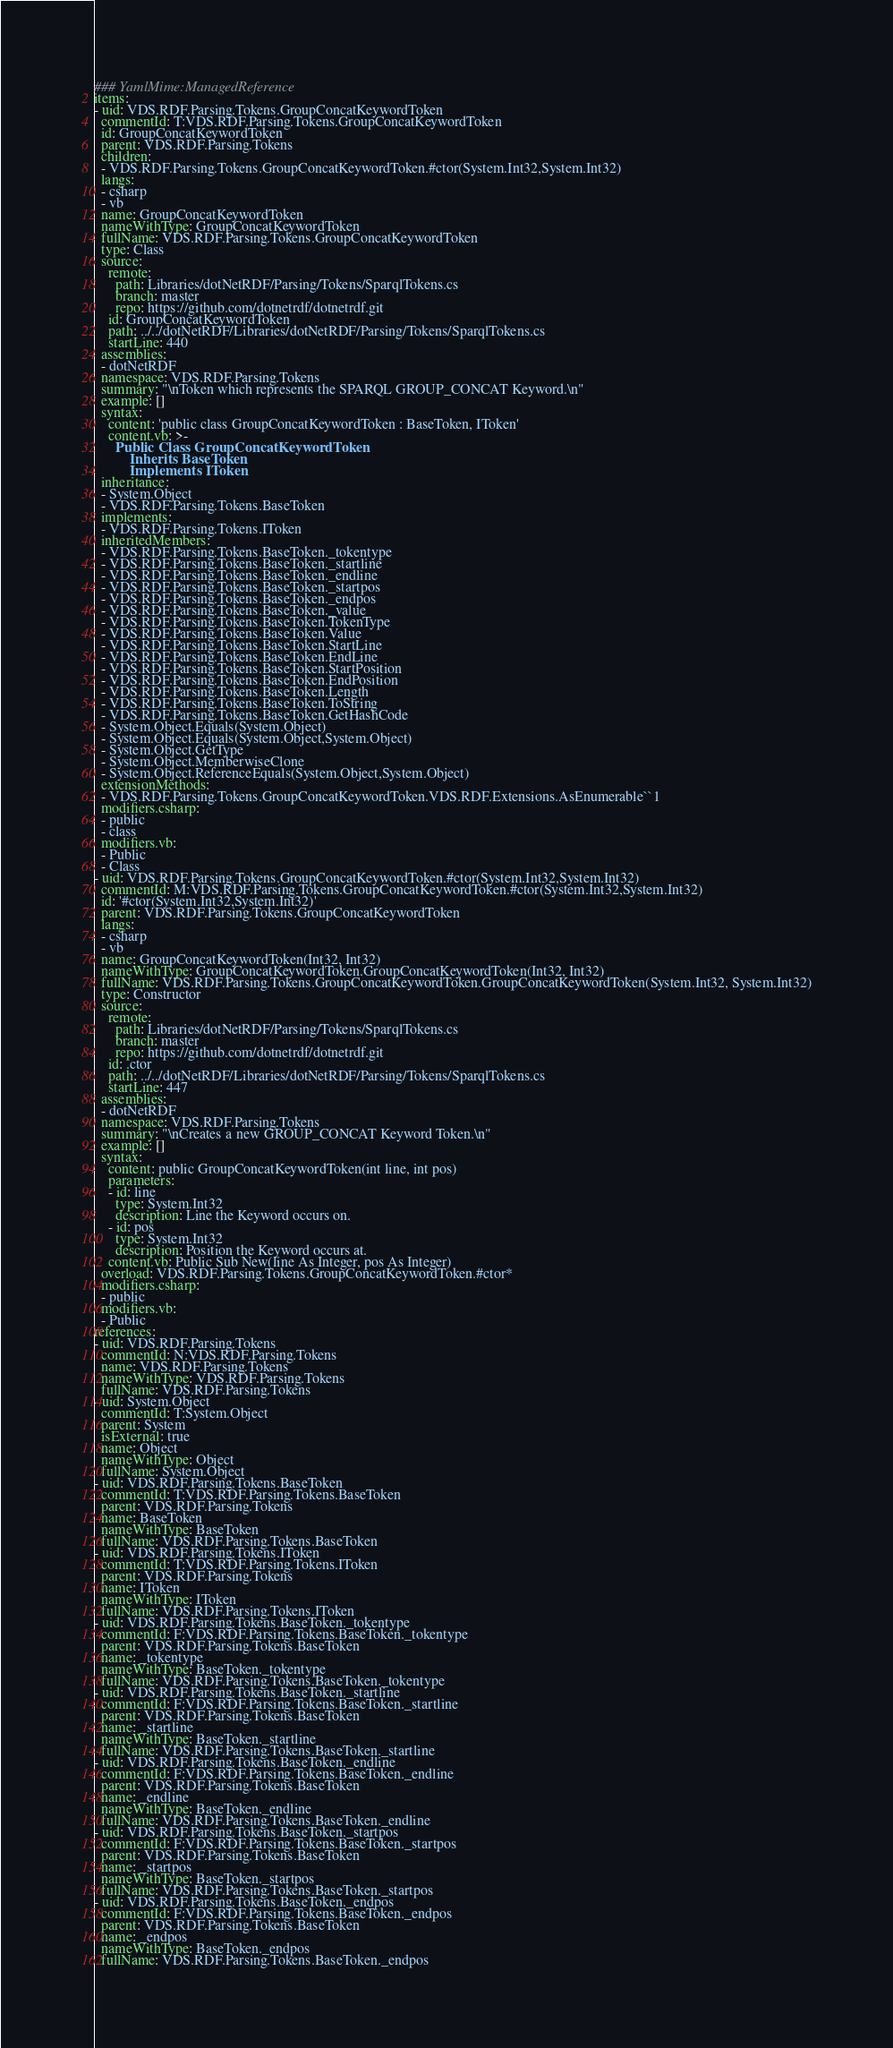Convert code to text. <code><loc_0><loc_0><loc_500><loc_500><_YAML_>### YamlMime:ManagedReference
items:
- uid: VDS.RDF.Parsing.Tokens.GroupConcatKeywordToken
  commentId: T:VDS.RDF.Parsing.Tokens.GroupConcatKeywordToken
  id: GroupConcatKeywordToken
  parent: VDS.RDF.Parsing.Tokens
  children:
  - VDS.RDF.Parsing.Tokens.GroupConcatKeywordToken.#ctor(System.Int32,System.Int32)
  langs:
  - csharp
  - vb
  name: GroupConcatKeywordToken
  nameWithType: GroupConcatKeywordToken
  fullName: VDS.RDF.Parsing.Tokens.GroupConcatKeywordToken
  type: Class
  source:
    remote:
      path: Libraries/dotNetRDF/Parsing/Tokens/SparqlTokens.cs
      branch: master
      repo: https://github.com/dotnetrdf/dotnetrdf.git
    id: GroupConcatKeywordToken
    path: ../../dotNetRDF/Libraries/dotNetRDF/Parsing/Tokens/SparqlTokens.cs
    startLine: 440
  assemblies:
  - dotNetRDF
  namespace: VDS.RDF.Parsing.Tokens
  summary: "\nToken which represents the SPARQL GROUP_CONCAT Keyword.\n"
  example: []
  syntax:
    content: 'public class GroupConcatKeywordToken : BaseToken, IToken'
    content.vb: >-
      Public Class GroupConcatKeywordToken
          Inherits BaseToken
          Implements IToken
  inheritance:
  - System.Object
  - VDS.RDF.Parsing.Tokens.BaseToken
  implements:
  - VDS.RDF.Parsing.Tokens.IToken
  inheritedMembers:
  - VDS.RDF.Parsing.Tokens.BaseToken._tokentype
  - VDS.RDF.Parsing.Tokens.BaseToken._startline
  - VDS.RDF.Parsing.Tokens.BaseToken._endline
  - VDS.RDF.Parsing.Tokens.BaseToken._startpos
  - VDS.RDF.Parsing.Tokens.BaseToken._endpos
  - VDS.RDF.Parsing.Tokens.BaseToken._value
  - VDS.RDF.Parsing.Tokens.BaseToken.TokenType
  - VDS.RDF.Parsing.Tokens.BaseToken.Value
  - VDS.RDF.Parsing.Tokens.BaseToken.StartLine
  - VDS.RDF.Parsing.Tokens.BaseToken.EndLine
  - VDS.RDF.Parsing.Tokens.BaseToken.StartPosition
  - VDS.RDF.Parsing.Tokens.BaseToken.EndPosition
  - VDS.RDF.Parsing.Tokens.BaseToken.Length
  - VDS.RDF.Parsing.Tokens.BaseToken.ToString
  - VDS.RDF.Parsing.Tokens.BaseToken.GetHashCode
  - System.Object.Equals(System.Object)
  - System.Object.Equals(System.Object,System.Object)
  - System.Object.GetType
  - System.Object.MemberwiseClone
  - System.Object.ReferenceEquals(System.Object,System.Object)
  extensionMethods:
  - VDS.RDF.Parsing.Tokens.GroupConcatKeywordToken.VDS.RDF.Extensions.AsEnumerable``1
  modifiers.csharp:
  - public
  - class
  modifiers.vb:
  - Public
  - Class
- uid: VDS.RDF.Parsing.Tokens.GroupConcatKeywordToken.#ctor(System.Int32,System.Int32)
  commentId: M:VDS.RDF.Parsing.Tokens.GroupConcatKeywordToken.#ctor(System.Int32,System.Int32)
  id: '#ctor(System.Int32,System.Int32)'
  parent: VDS.RDF.Parsing.Tokens.GroupConcatKeywordToken
  langs:
  - csharp
  - vb
  name: GroupConcatKeywordToken(Int32, Int32)
  nameWithType: GroupConcatKeywordToken.GroupConcatKeywordToken(Int32, Int32)
  fullName: VDS.RDF.Parsing.Tokens.GroupConcatKeywordToken.GroupConcatKeywordToken(System.Int32, System.Int32)
  type: Constructor
  source:
    remote:
      path: Libraries/dotNetRDF/Parsing/Tokens/SparqlTokens.cs
      branch: master
      repo: https://github.com/dotnetrdf/dotnetrdf.git
    id: .ctor
    path: ../../dotNetRDF/Libraries/dotNetRDF/Parsing/Tokens/SparqlTokens.cs
    startLine: 447
  assemblies:
  - dotNetRDF
  namespace: VDS.RDF.Parsing.Tokens
  summary: "\nCreates a new GROUP_CONCAT Keyword Token.\n"
  example: []
  syntax:
    content: public GroupConcatKeywordToken(int line, int pos)
    parameters:
    - id: line
      type: System.Int32
      description: Line the Keyword occurs on.
    - id: pos
      type: System.Int32
      description: Position the Keyword occurs at.
    content.vb: Public Sub New(line As Integer, pos As Integer)
  overload: VDS.RDF.Parsing.Tokens.GroupConcatKeywordToken.#ctor*
  modifiers.csharp:
  - public
  modifiers.vb:
  - Public
references:
- uid: VDS.RDF.Parsing.Tokens
  commentId: N:VDS.RDF.Parsing.Tokens
  name: VDS.RDF.Parsing.Tokens
  nameWithType: VDS.RDF.Parsing.Tokens
  fullName: VDS.RDF.Parsing.Tokens
- uid: System.Object
  commentId: T:System.Object
  parent: System
  isExternal: true
  name: Object
  nameWithType: Object
  fullName: System.Object
- uid: VDS.RDF.Parsing.Tokens.BaseToken
  commentId: T:VDS.RDF.Parsing.Tokens.BaseToken
  parent: VDS.RDF.Parsing.Tokens
  name: BaseToken
  nameWithType: BaseToken
  fullName: VDS.RDF.Parsing.Tokens.BaseToken
- uid: VDS.RDF.Parsing.Tokens.IToken
  commentId: T:VDS.RDF.Parsing.Tokens.IToken
  parent: VDS.RDF.Parsing.Tokens
  name: IToken
  nameWithType: IToken
  fullName: VDS.RDF.Parsing.Tokens.IToken
- uid: VDS.RDF.Parsing.Tokens.BaseToken._tokentype
  commentId: F:VDS.RDF.Parsing.Tokens.BaseToken._tokentype
  parent: VDS.RDF.Parsing.Tokens.BaseToken
  name: _tokentype
  nameWithType: BaseToken._tokentype
  fullName: VDS.RDF.Parsing.Tokens.BaseToken._tokentype
- uid: VDS.RDF.Parsing.Tokens.BaseToken._startline
  commentId: F:VDS.RDF.Parsing.Tokens.BaseToken._startline
  parent: VDS.RDF.Parsing.Tokens.BaseToken
  name: _startline
  nameWithType: BaseToken._startline
  fullName: VDS.RDF.Parsing.Tokens.BaseToken._startline
- uid: VDS.RDF.Parsing.Tokens.BaseToken._endline
  commentId: F:VDS.RDF.Parsing.Tokens.BaseToken._endline
  parent: VDS.RDF.Parsing.Tokens.BaseToken
  name: _endline
  nameWithType: BaseToken._endline
  fullName: VDS.RDF.Parsing.Tokens.BaseToken._endline
- uid: VDS.RDF.Parsing.Tokens.BaseToken._startpos
  commentId: F:VDS.RDF.Parsing.Tokens.BaseToken._startpos
  parent: VDS.RDF.Parsing.Tokens.BaseToken
  name: _startpos
  nameWithType: BaseToken._startpos
  fullName: VDS.RDF.Parsing.Tokens.BaseToken._startpos
- uid: VDS.RDF.Parsing.Tokens.BaseToken._endpos
  commentId: F:VDS.RDF.Parsing.Tokens.BaseToken._endpos
  parent: VDS.RDF.Parsing.Tokens.BaseToken
  name: _endpos
  nameWithType: BaseToken._endpos
  fullName: VDS.RDF.Parsing.Tokens.BaseToken._endpos</code> 